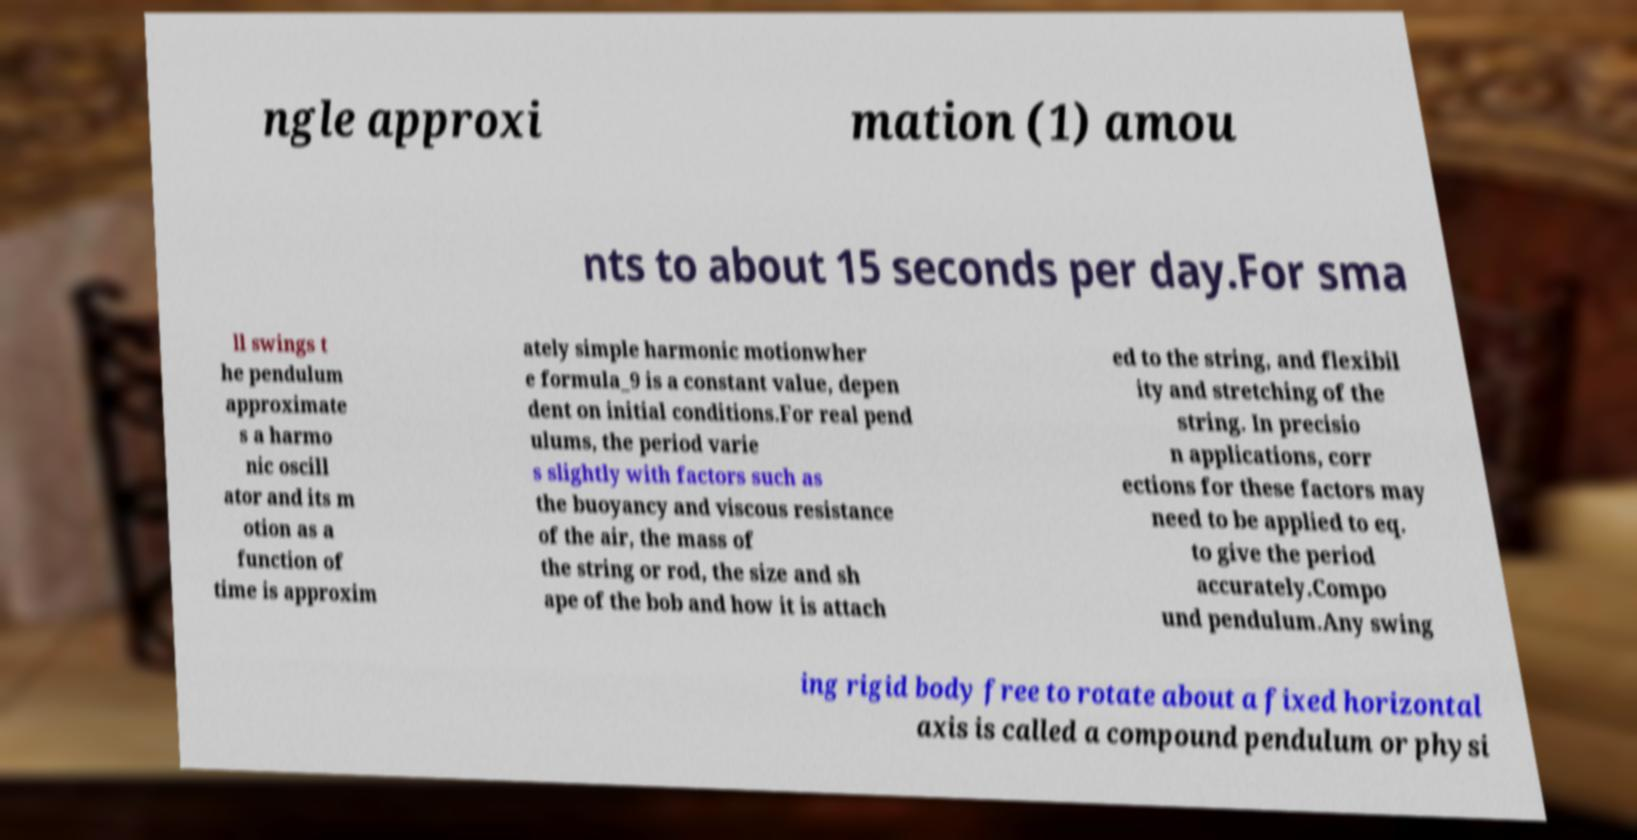For documentation purposes, I need the text within this image transcribed. Could you provide that? ngle approxi mation (1) amou nts to about 15 seconds per day.For sma ll swings t he pendulum approximate s a harmo nic oscill ator and its m otion as a function of time is approxim ately simple harmonic motionwher e formula_9 is a constant value, depen dent on initial conditions.For real pend ulums, the period varie s slightly with factors such as the buoyancy and viscous resistance of the air, the mass of the string or rod, the size and sh ape of the bob and how it is attach ed to the string, and flexibil ity and stretching of the string. In precisio n applications, corr ections for these factors may need to be applied to eq. to give the period accurately.Compo und pendulum.Any swing ing rigid body free to rotate about a fixed horizontal axis is called a compound pendulum or physi 